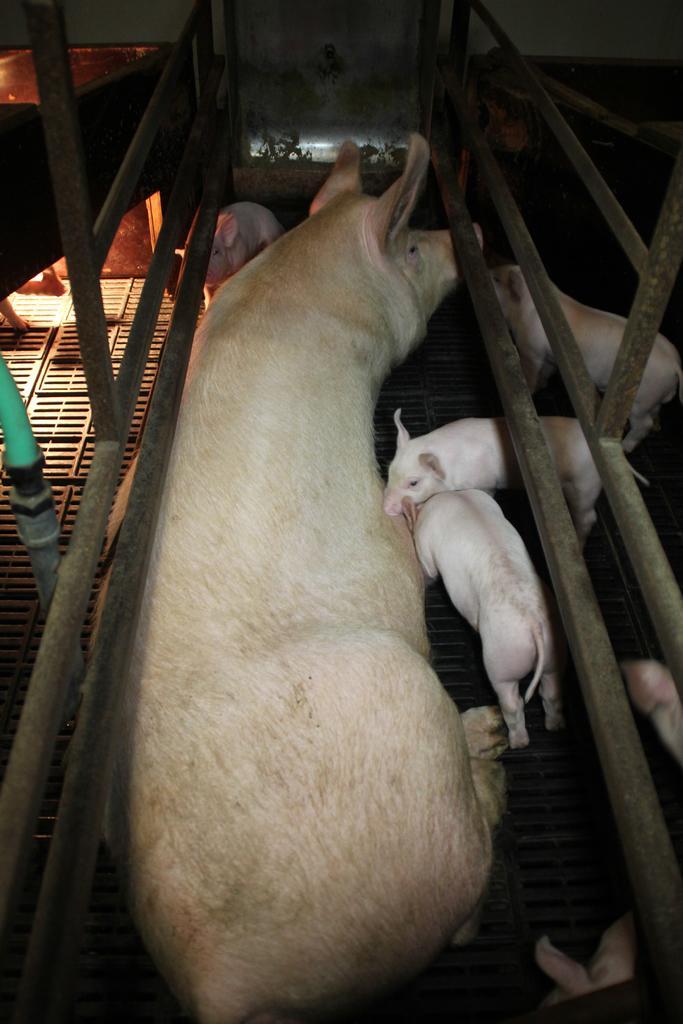How would you summarize this image in a sentence or two? In this picture I can see some small pigs and big pig. Beside that I can see the pipes and fencing. At the top there is a door and wall. 